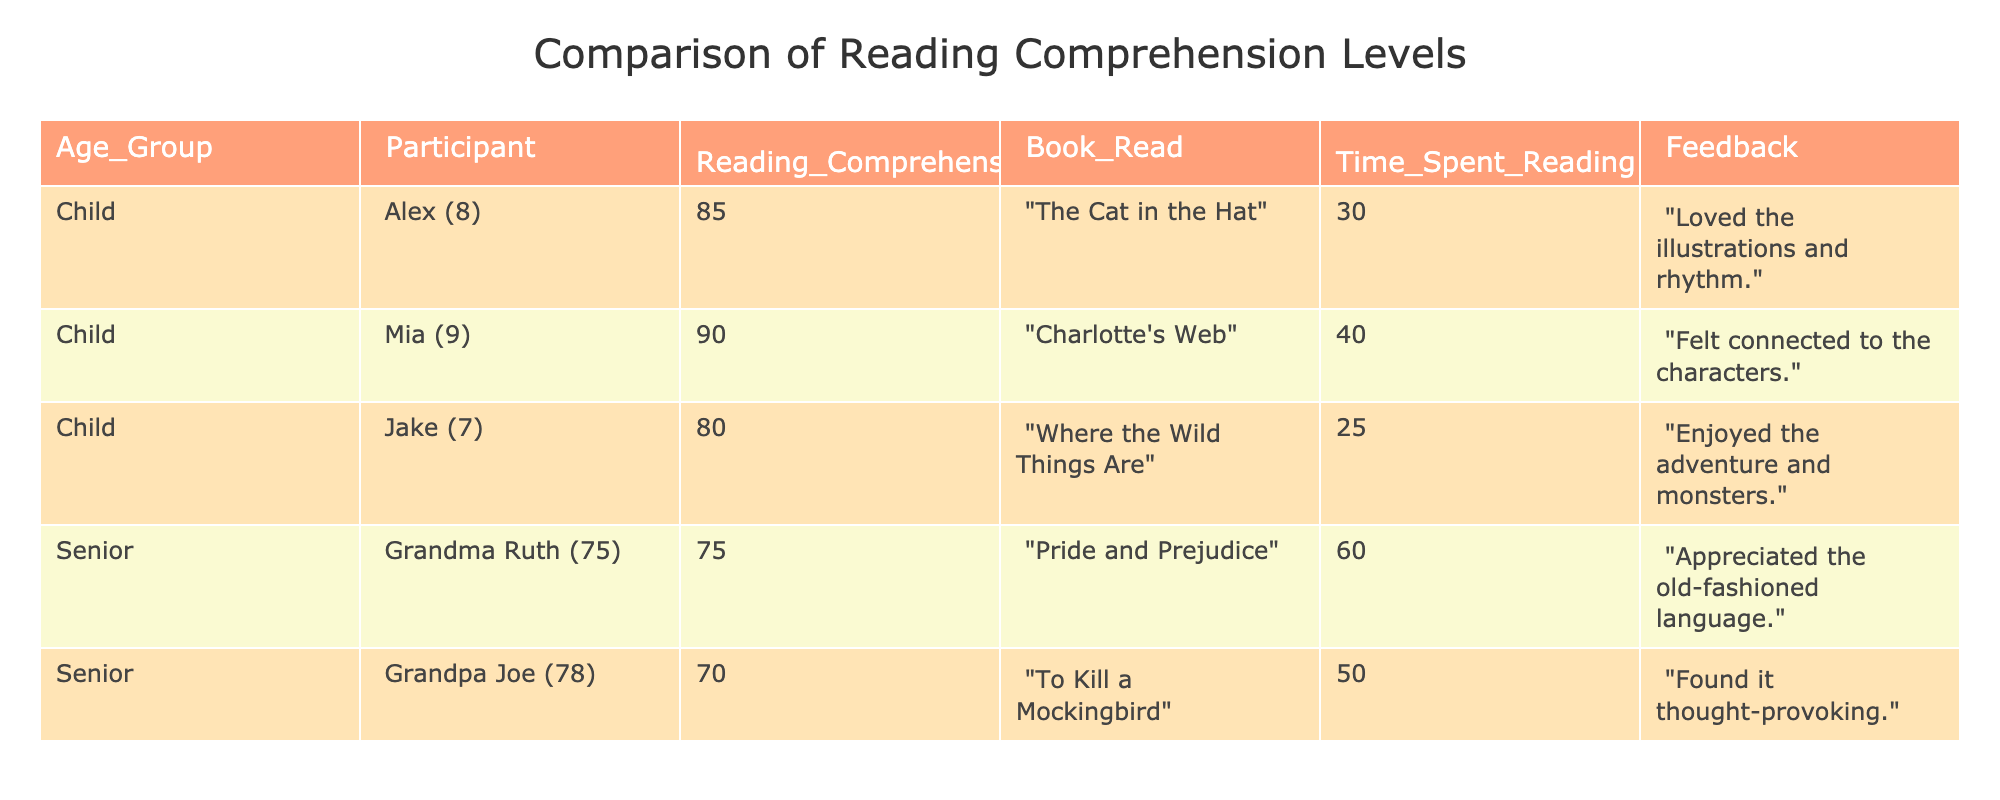What is the reading comprehension score of Alex? In the table, the row for Alex states "Reading_Comprehension_Score" as 85. Therefore, the score for Alex is directly taken from this information.
Answer: 85 What book did Mia read? The table indicates that Mia (9) read "Charlotte's Web". This is found in the corresponding row under the "Book_Read" column.
Answer: "Charlotte's Web" What is the average reading comprehension score for seniors? To find the average score, we add the scores for all seniors: 75 (Grandma Ruth) + 70 (Grandpa Joe) = 145. There are 2 seniors, so the average is 145 / 2 = 72.5.
Answer: 72.5 Did Jake read for more or less than 30 minutes? Jake's "Time_Spent_Reading" is stated as 25 minutes, which is indeed less than 30 minutes, making this a true statement.
Answer: Less Which age group has a higher average reading comprehension score? First, we calculate the average for each group. For children: (85 + 90 + 80) / 3 = 85. For seniors: (75 + 70) / 2 = 72.5. Since 85 > 72.5, children have a higher average.
Answer: Children What feedback did Grandpa Joe give about the book he read? Grandpa Joe's feedback is explicitly stated in the table: "Found it thought-provoking." This can be directly referenced from his row.
Answer: "Found it thought-provoking." Is the reading comprehension score of any child below 80? By reviewing the children's scores (85, 90, 80), none of them have a score below 80. Therefore, this statement is false.
Answer: No What was the total time spent reading by all participants? Summing up the time spent reading: 30 (Alex) + 40 (Mia) + 25 (Jake) + 60 (Grandma Ruth) + 50 (Grandpa Joe) = 205 minutes total.
Answer: 205 What book did Grandma Ruth read, and how did she feel about it? Grandma Ruth read "Pride and Prejudice" and her feedback indicates she "Appreciated the old-fashioned language," which is taken directly from her row in the table.
Answer: "Pride and Prejudice", "Appreciated the old-fashioned language" 